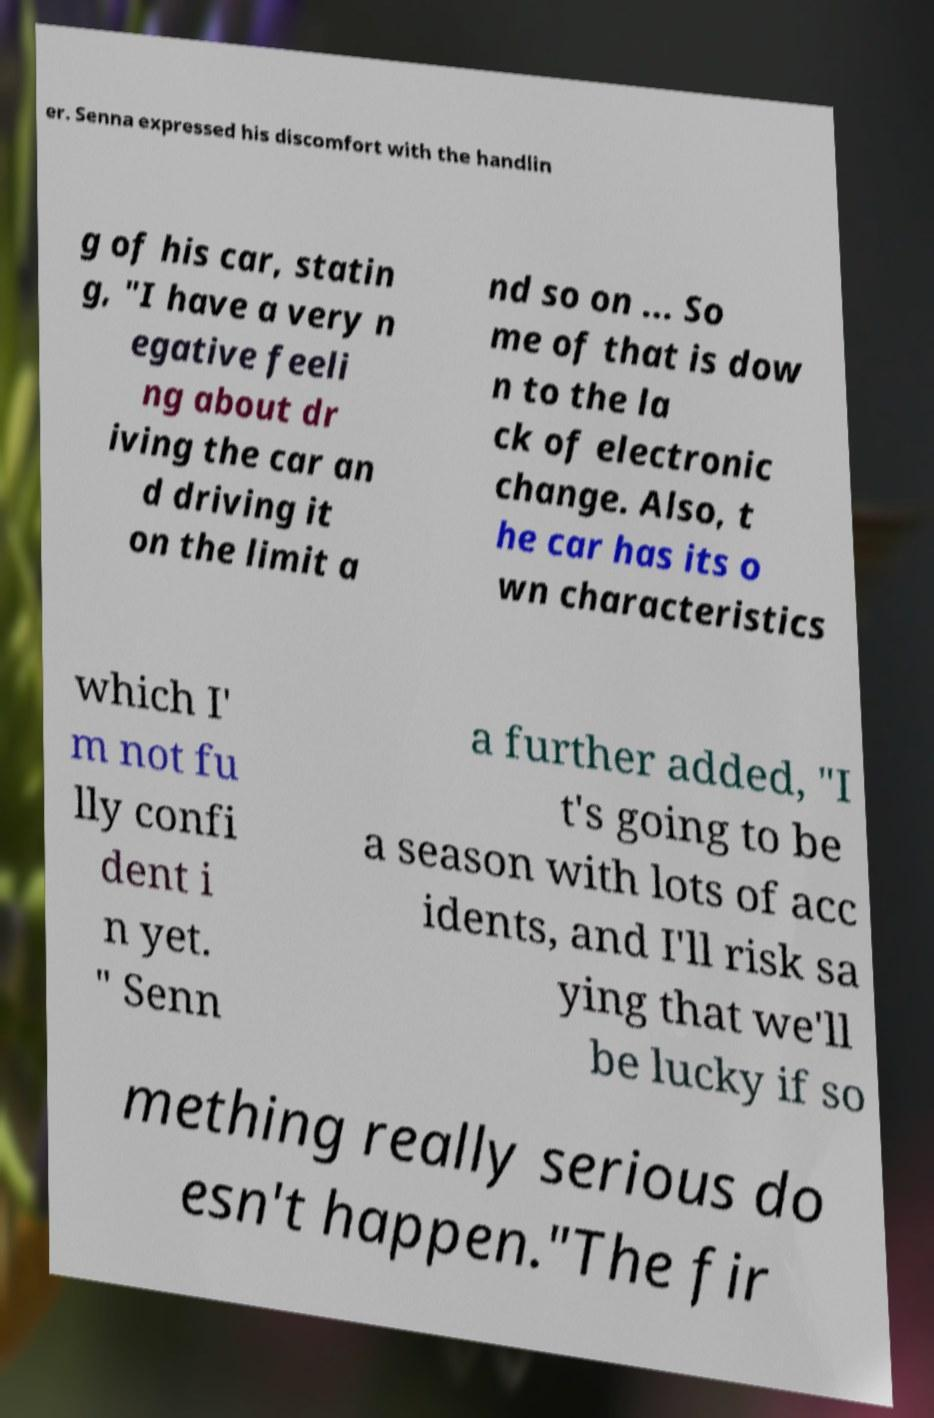Please read and relay the text visible in this image. What does it say? er. Senna expressed his discomfort with the handlin g of his car, statin g, "I have a very n egative feeli ng about dr iving the car an d driving it on the limit a nd so on ... So me of that is dow n to the la ck of electronic change. Also, t he car has its o wn characteristics which I' m not fu lly confi dent i n yet. " Senn a further added, "I t's going to be a season with lots of acc idents, and I'll risk sa ying that we'll be lucky if so mething really serious do esn't happen."The fir 